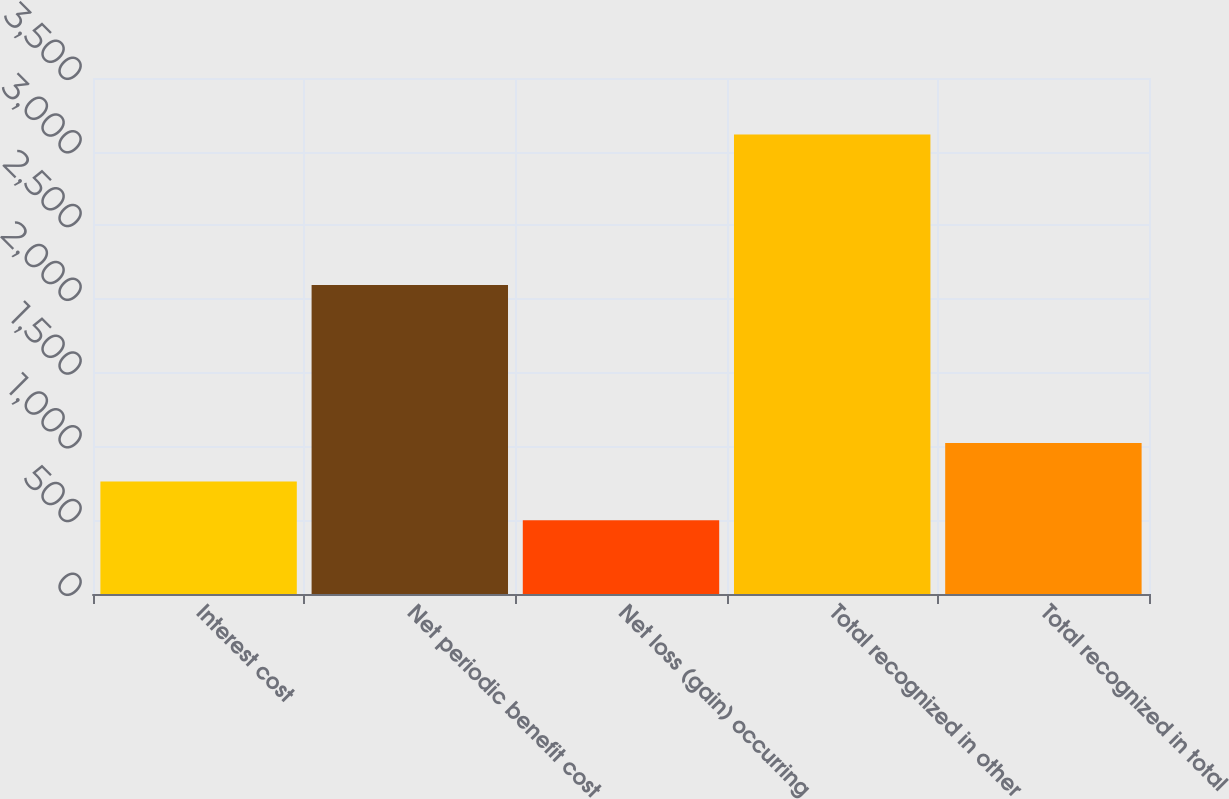<chart> <loc_0><loc_0><loc_500><loc_500><bar_chart><fcel>Interest cost<fcel>Net periodic benefit cost<fcel>Net loss (gain) occurring<fcel>Total recognized in other<fcel>Total recognized in total<nl><fcel>762.5<fcel>2096<fcel>501<fcel>3116<fcel>1024<nl></chart> 